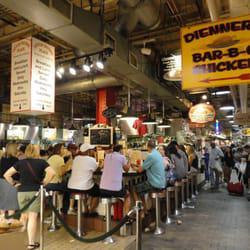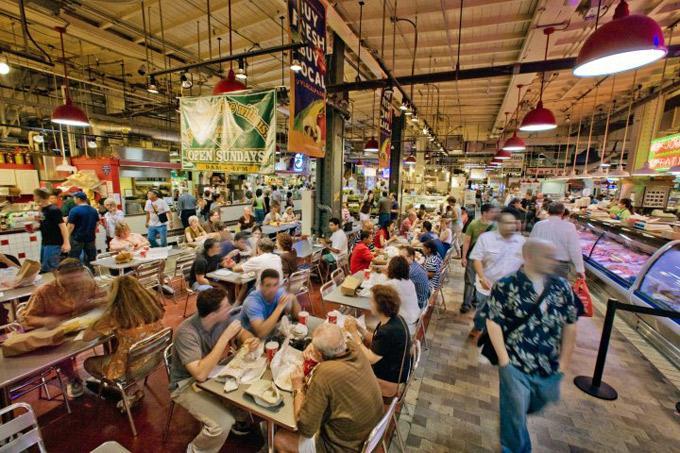The first image is the image on the left, the second image is the image on the right. Given the left and right images, does the statement "In at least one image the is a menu framed in red sitting on a black countertop." hold true? Answer yes or no. No. The first image is the image on the left, the second image is the image on the right. Analyze the images presented: Is the assertion "More than six people are sitting on bar stools." valid? Answer yes or no. Yes. 